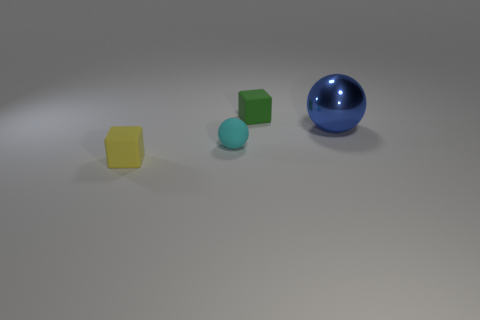How many large spheres are there?
Provide a succinct answer. 1. How many other tiny things are the same material as the yellow thing?
Offer a terse response. 2. There is another cyan thing that is the same shape as the big metal thing; what size is it?
Your answer should be very brief. Small. What is the material of the green cube?
Your response must be concise. Rubber. What is the tiny block that is in front of the small block to the right of the cube that is in front of the tiny green block made of?
Offer a very short reply. Rubber. Is there any other thing that is the same shape as the large metallic thing?
Ensure brevity in your answer.  Yes. There is another matte thing that is the same shape as the tiny yellow object; what is its color?
Make the answer very short. Green. There is a matte cube that is behind the blue metal object; is it the same color as the small matte block in front of the big thing?
Provide a succinct answer. No. Are there more tiny spheres to the left of the cyan rubber thing than large rubber blocks?
Your answer should be compact. No. What number of other objects are the same size as the yellow matte thing?
Make the answer very short. 2. 